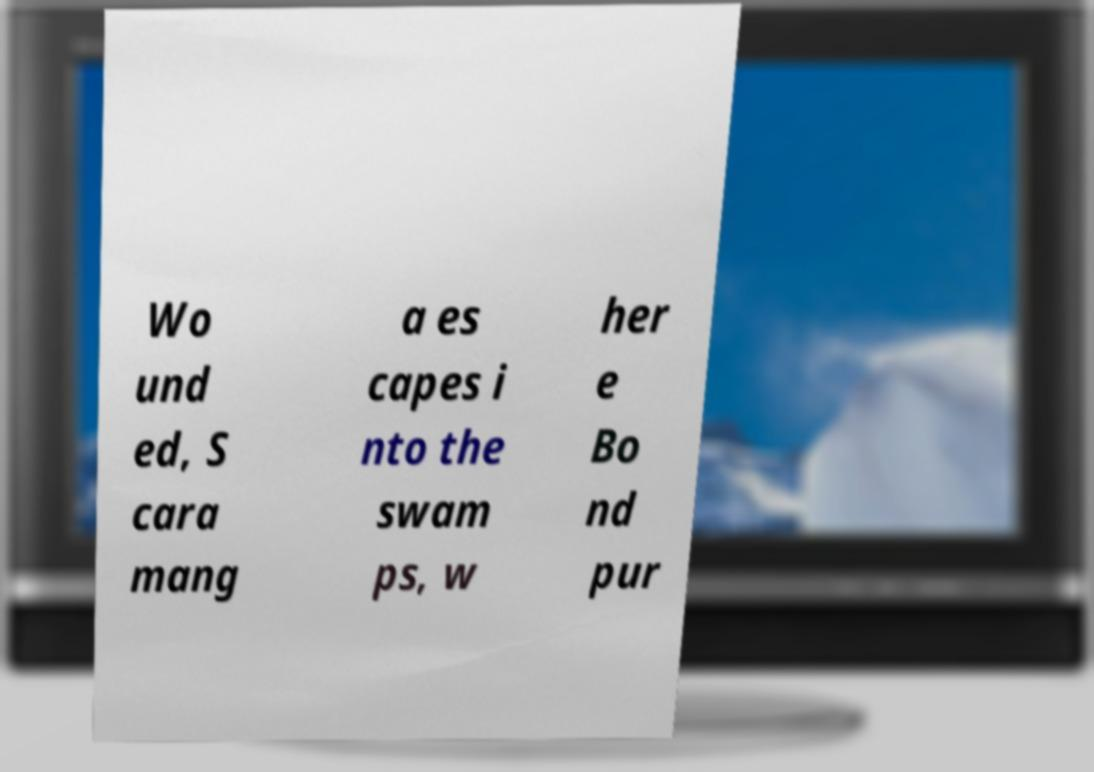There's text embedded in this image that I need extracted. Can you transcribe it verbatim? Wo und ed, S cara mang a es capes i nto the swam ps, w her e Bo nd pur 